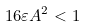Convert formula to latex. <formula><loc_0><loc_0><loc_500><loc_500>1 6 \varepsilon A ^ { 2 } < 1</formula> 